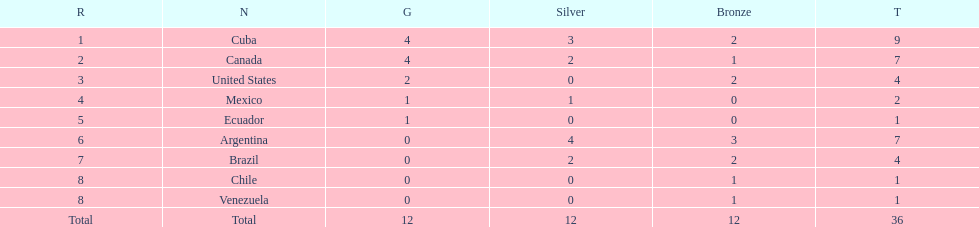How many total medals did brazil received? 4. 